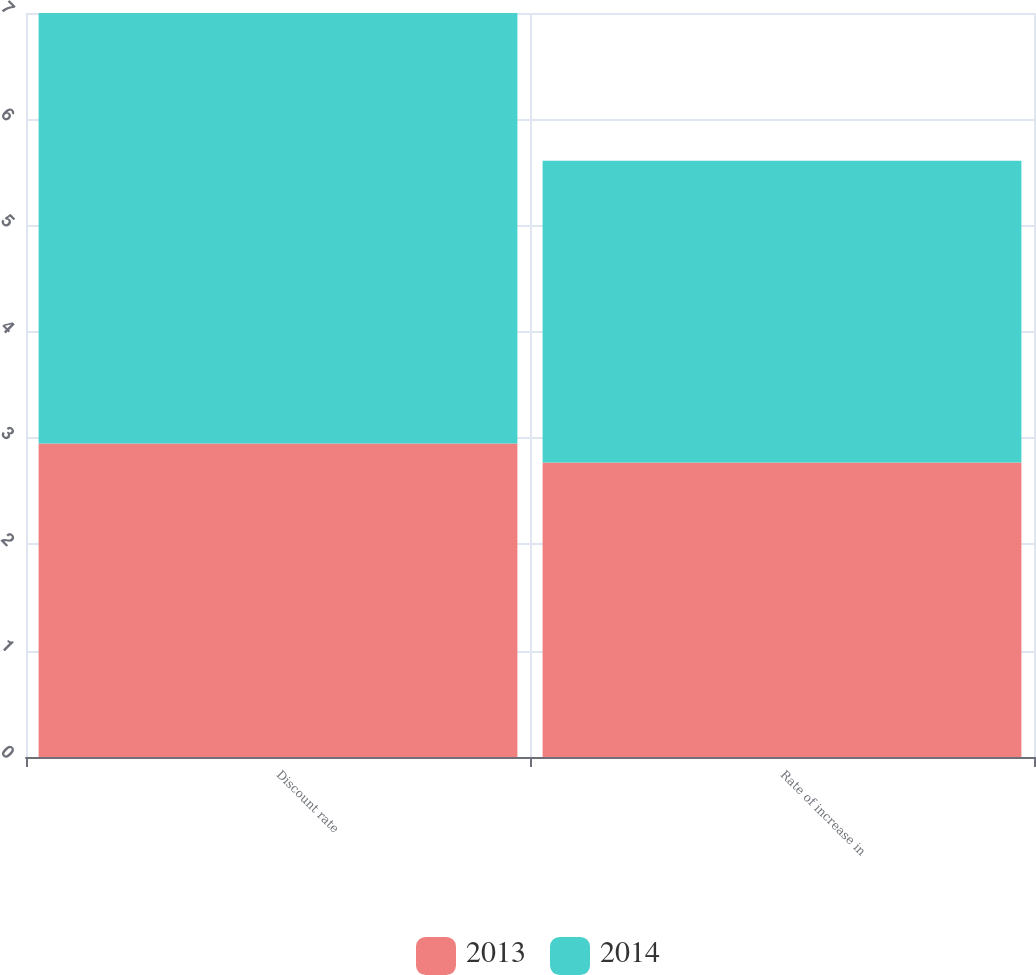Convert chart to OTSL. <chart><loc_0><loc_0><loc_500><loc_500><stacked_bar_chart><ecel><fcel>Discount rate<fcel>Rate of increase in<nl><fcel>2013<fcel>2.95<fcel>2.77<nl><fcel>2014<fcel>4.05<fcel>2.84<nl></chart> 